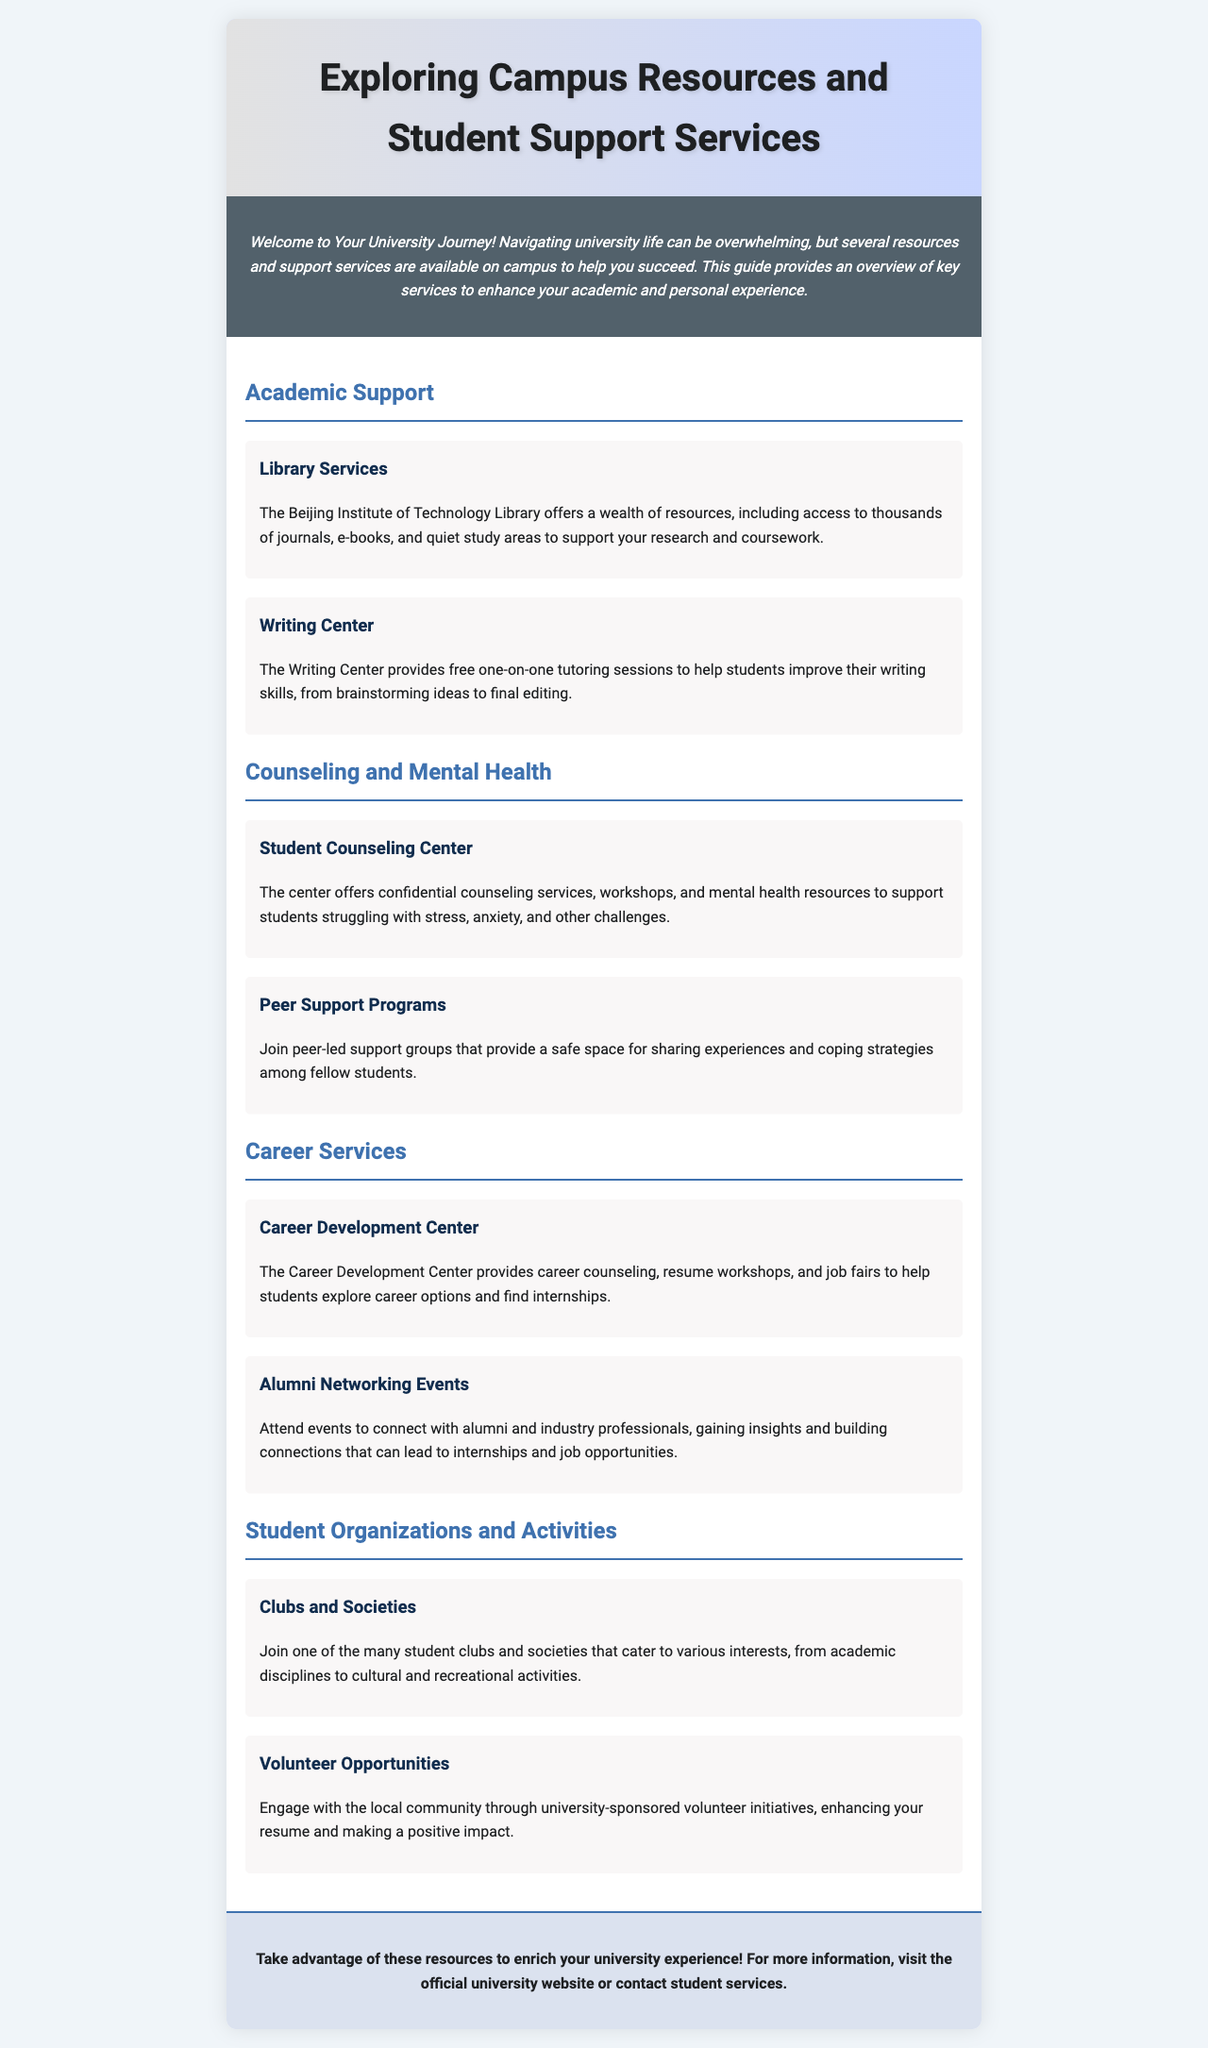what is the title of the brochure? The title of the brochure is prominently displayed at the top of the document.
Answer: Exploring Campus Resources and Student Support Services which center offers free one-on-one tutoring sessions? The document states that the Writing Center provides this service for students.
Answer: Writing Center what mental health resource is available for students? The document lists the Student Counseling Center as a resource available for mental health support.
Answer: Student Counseling Center how many sections are in the content area? The content area includes multiple sections, providing specific information about services offered.
Answer: Four what kind of events does the Alumni Networking section reference? This section mentions events that help students connect with alumni and professionals.
Answer: Networking Events which service helps with resume workshops? The Career Development Center is identified as the service that provides assistance with resume workshops.
Answer: Career Development Center what opportunities are mentioned for engaging with the local community? The document states there are volunteer initiatives sponsored by the university for this purpose.
Answer: Volunteer Opportunities which types of student clubs are highlighted? The document mentions clubs and societies catering to various interests, including academic and cultural activities.
Answer: Clubs and Societies what is the overall purpose of the brochure? The introduction states that the brochure aims to help students navigate university life by providing information on resources and support services.
Answer: Help students succeed 